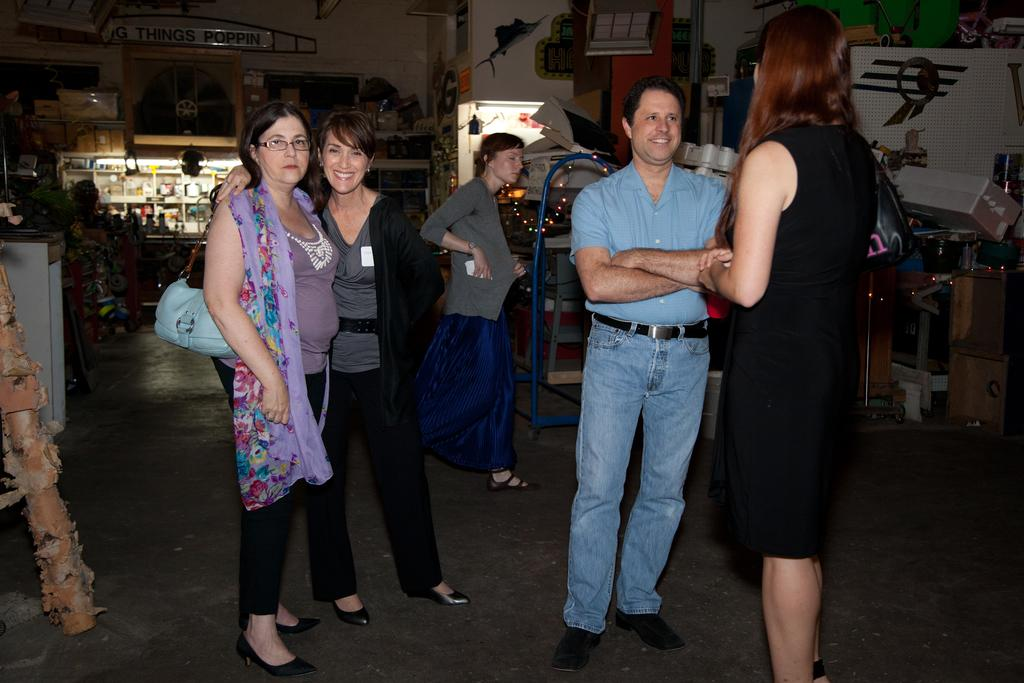How many people are in the image? There are multiple persons standing in the image. What is visible at the bottom of the image? There is ground visible at the bottom of the image. What can be seen in the background of the image? There are various unspecified elements in the background of the image, including at least one building. What type of haircut does the building in the image have? There is no haircut present in the image, as the building is an inanimate object and cannot have a haircut. 